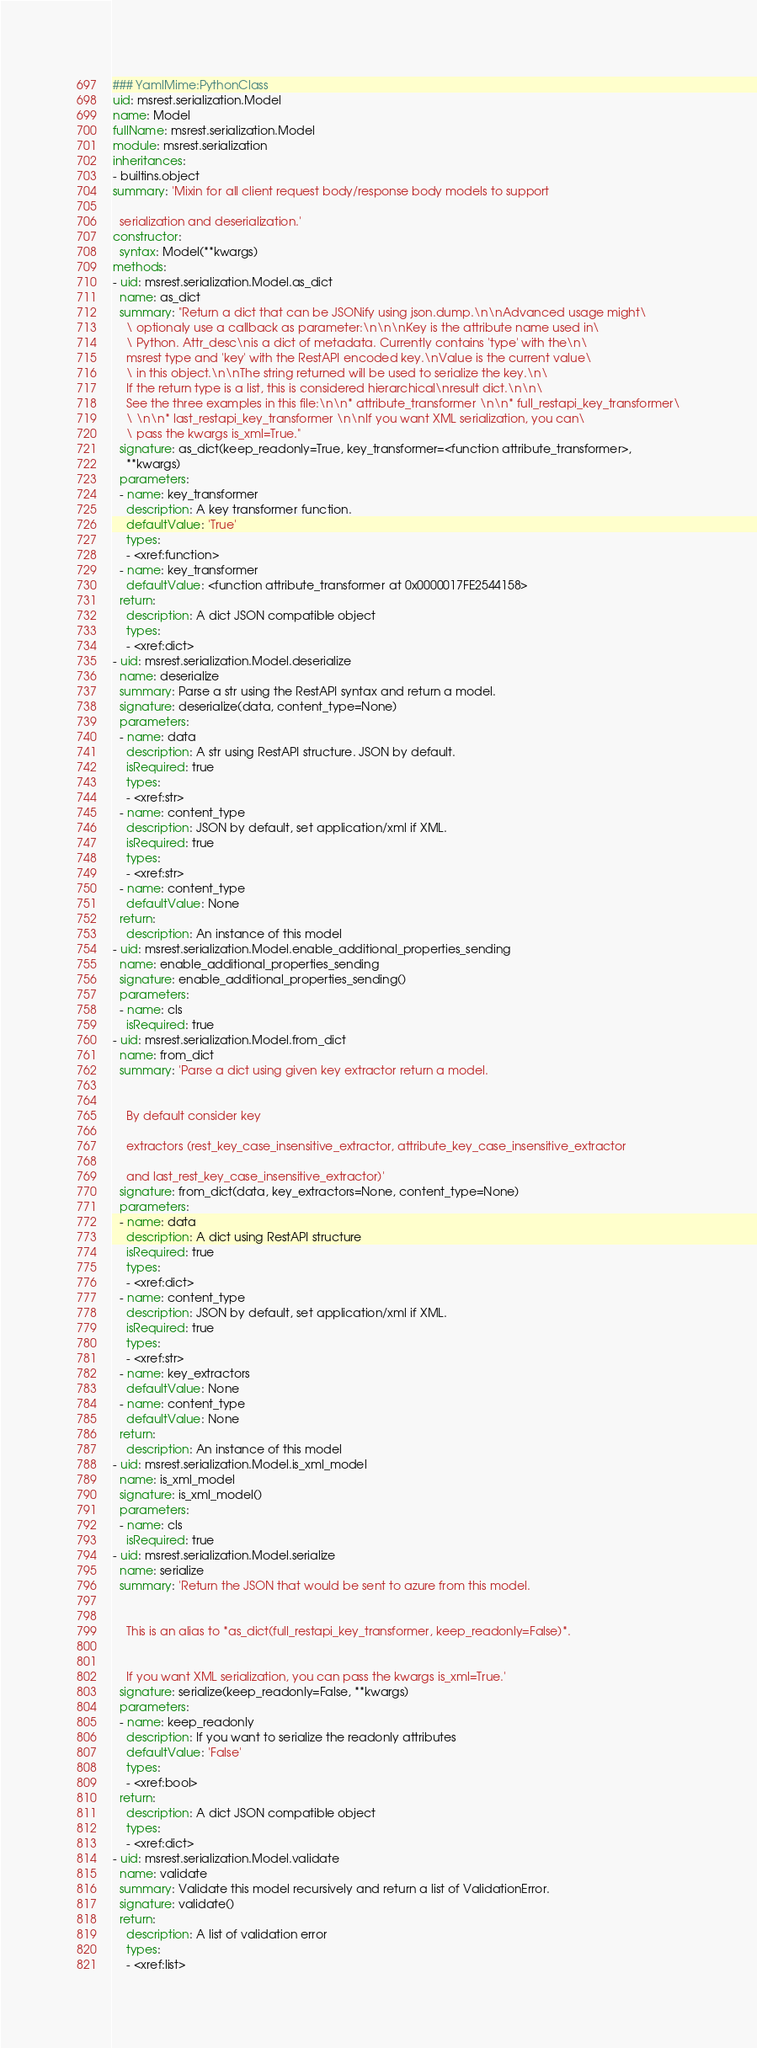Convert code to text. <code><loc_0><loc_0><loc_500><loc_500><_YAML_>### YamlMime:PythonClass
uid: msrest.serialization.Model
name: Model
fullName: msrest.serialization.Model
module: msrest.serialization
inheritances:
- builtins.object
summary: 'Mixin for all client request body/response body models to support

  serialization and deserialization.'
constructor:
  syntax: Model(**kwargs)
methods:
- uid: msrest.serialization.Model.as_dict
  name: as_dict
  summary: "Return a dict that can be JSONify using json.dump.\n\nAdvanced usage might\
    \ optionaly use a callback as parameter:\n\n\nKey is the attribute name used in\
    \ Python. Attr_desc\nis a dict of metadata. Currently contains 'type' with the\n\
    msrest type and 'key' with the RestAPI encoded key.\nValue is the current value\
    \ in this object.\n\nThe string returned will be used to serialize the key.\n\
    If the return type is a list, this is considered hierarchical\nresult dict.\n\n\
    See the three examples in this file:\n\n* attribute_transformer \n\n* full_restapi_key_transformer\
    \ \n\n* last_restapi_key_transformer \n\nIf you want XML serialization, you can\
    \ pass the kwargs is_xml=True."
  signature: as_dict(keep_readonly=True, key_transformer=<function attribute_transformer>,
    **kwargs)
  parameters:
  - name: key_transformer
    description: A key transformer function.
    defaultValue: 'True'
    types:
    - <xref:function>
  - name: key_transformer
    defaultValue: <function attribute_transformer at 0x0000017FE2544158>
  return:
    description: A dict JSON compatible object
    types:
    - <xref:dict>
- uid: msrest.serialization.Model.deserialize
  name: deserialize
  summary: Parse a str using the RestAPI syntax and return a model.
  signature: deserialize(data, content_type=None)
  parameters:
  - name: data
    description: A str using RestAPI structure. JSON by default.
    isRequired: true
    types:
    - <xref:str>
  - name: content_type
    description: JSON by default, set application/xml if XML.
    isRequired: true
    types:
    - <xref:str>
  - name: content_type
    defaultValue: None
  return:
    description: An instance of this model
- uid: msrest.serialization.Model.enable_additional_properties_sending
  name: enable_additional_properties_sending
  signature: enable_additional_properties_sending()
  parameters:
  - name: cls
    isRequired: true
- uid: msrest.serialization.Model.from_dict
  name: from_dict
  summary: 'Parse a dict using given key extractor return a model.


    By default consider key

    extractors (rest_key_case_insensitive_extractor, attribute_key_case_insensitive_extractor

    and last_rest_key_case_insensitive_extractor)'
  signature: from_dict(data, key_extractors=None, content_type=None)
  parameters:
  - name: data
    description: A dict using RestAPI structure
    isRequired: true
    types:
    - <xref:dict>
  - name: content_type
    description: JSON by default, set application/xml if XML.
    isRequired: true
    types:
    - <xref:str>
  - name: key_extractors
    defaultValue: None
  - name: content_type
    defaultValue: None
  return:
    description: An instance of this model
- uid: msrest.serialization.Model.is_xml_model
  name: is_xml_model
  signature: is_xml_model()
  parameters:
  - name: cls
    isRequired: true
- uid: msrest.serialization.Model.serialize
  name: serialize
  summary: 'Return the JSON that would be sent to azure from this model.


    This is an alias to *as_dict(full_restapi_key_transformer, keep_readonly=False)*.


    If you want XML serialization, you can pass the kwargs is_xml=True.'
  signature: serialize(keep_readonly=False, **kwargs)
  parameters:
  - name: keep_readonly
    description: If you want to serialize the readonly attributes
    defaultValue: 'False'
    types:
    - <xref:bool>
  return:
    description: A dict JSON compatible object
    types:
    - <xref:dict>
- uid: msrest.serialization.Model.validate
  name: validate
  summary: Validate this model recursively and return a list of ValidationError.
  signature: validate()
  return:
    description: A list of validation error
    types:
    - <xref:list>
</code> 